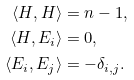<formula> <loc_0><loc_0><loc_500><loc_500>\langle H , H \rangle & = n - 1 , \\ \langle H , E _ { i } \rangle & = 0 , \\ \langle E _ { i } , E _ { j } \rangle & = - \delta _ { i , j } .</formula> 